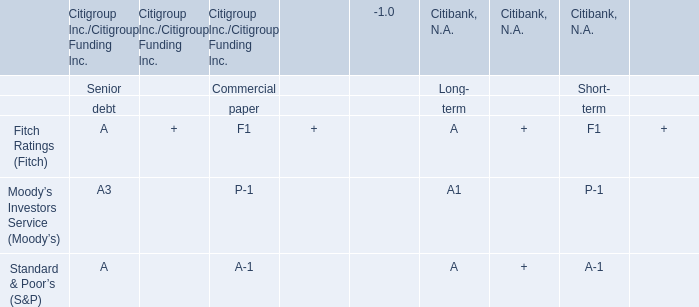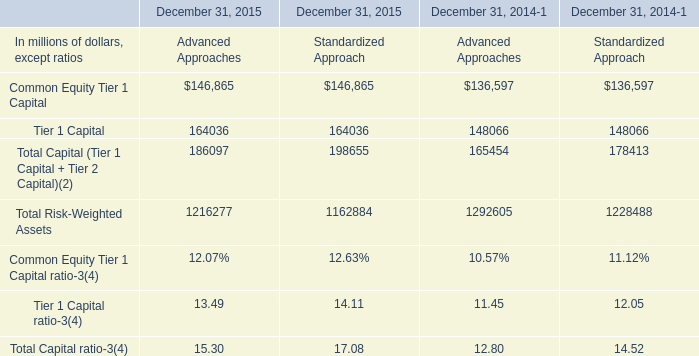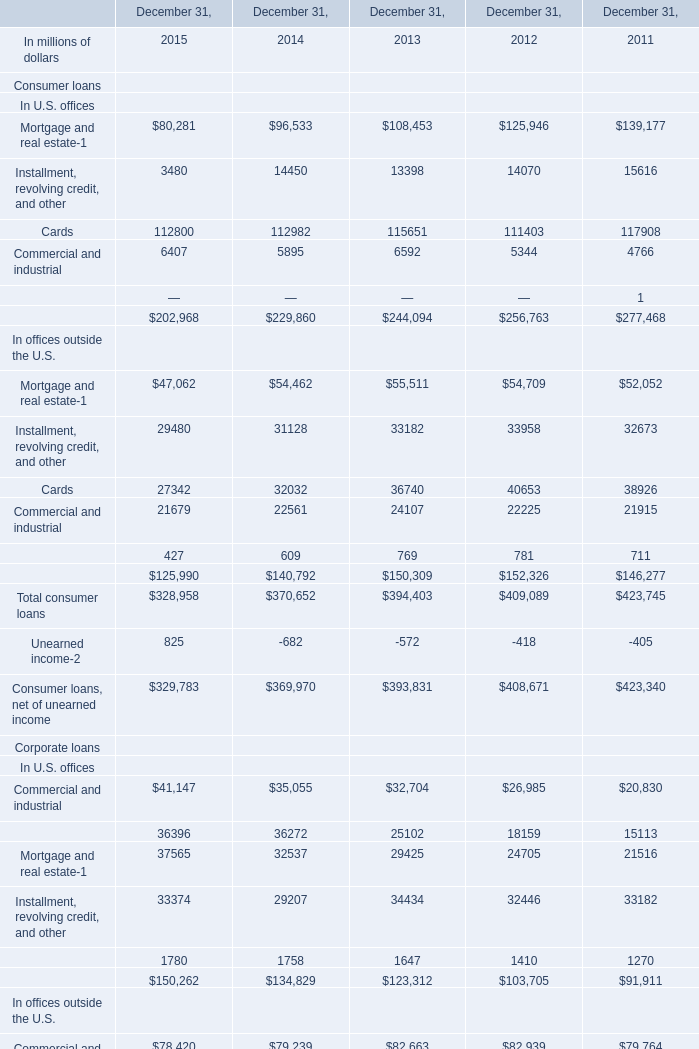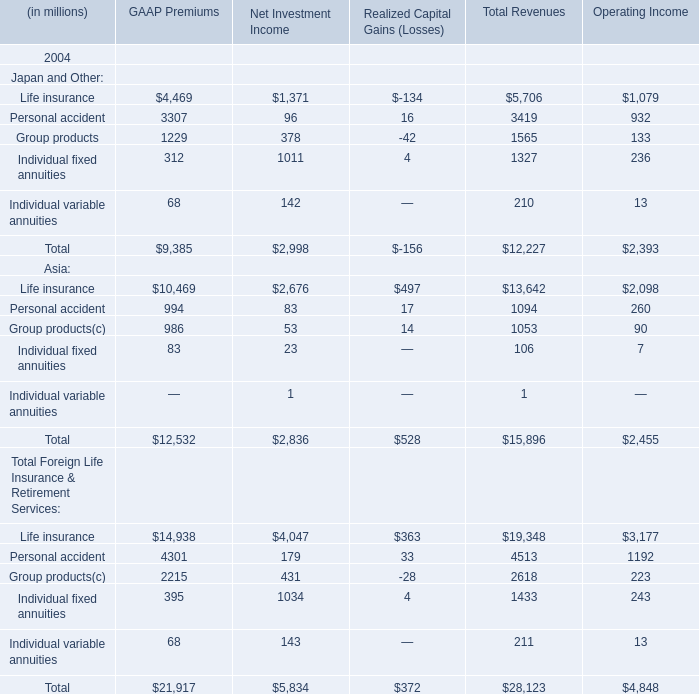What's the average of Tier 1 Capital of December 31, 2014 Advanced Approaches, and Lease financing In U.S. offices of December 31, 2013 ? 
Computations: ((148066.0 + 1647.0) / 2)
Answer: 74856.5. 